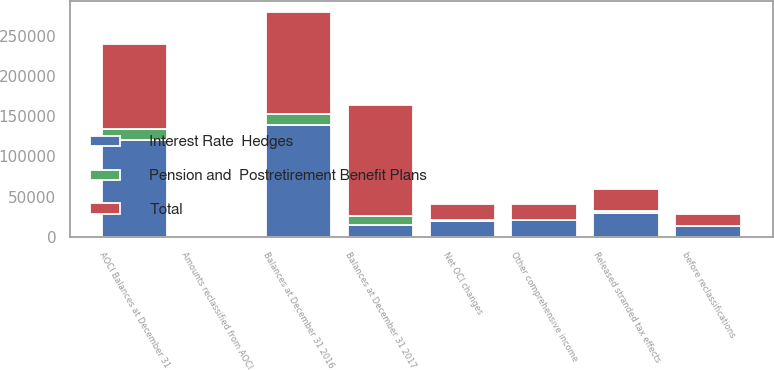<chart> <loc_0><loc_0><loc_500><loc_500><stacked_bar_chart><ecel><fcel>AOCI Balances at December 31<fcel>Other comprehensive income<fcel>Amounts reclassified from AOCI<fcel>Net OCI changes<fcel>Balances at December 31 2016<fcel>before reclassifications<fcel>Balances at December 31 2017<fcel>Released stranded tax effects<nl><fcel>Pension and  Postretirement Benefit Plans<fcel>14494<fcel>0<fcel>1194<fcel>1194<fcel>13300<fcel>0<fcel>11438<fcel>2464<nl><fcel>Total<fcel>105575<fcel>20583<fcel>82<fcel>20501<fcel>126076<fcel>14106<fcel>138028<fcel>27165<nl><fcel>Interest Rate  Hedges<fcel>120069<fcel>20583<fcel>1276<fcel>19307<fcel>139376<fcel>14106<fcel>14494<fcel>29629<nl></chart> 